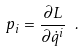<formula> <loc_0><loc_0><loc_500><loc_500>p _ { i } = \frac { \partial L } { \partial \dot { q } ^ { i } } \ .</formula> 